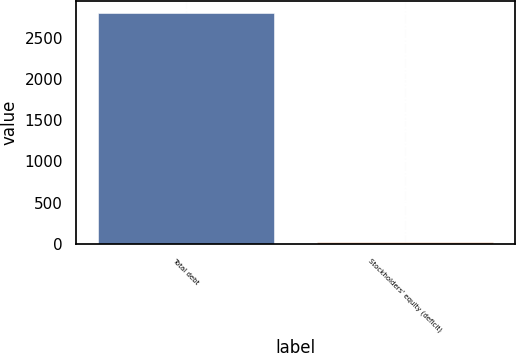Convert chart to OTSL. <chart><loc_0><loc_0><loc_500><loc_500><bar_chart><fcel>Total debt<fcel>Stockholders' equity (deficit)<nl><fcel>2805<fcel>20<nl></chart> 